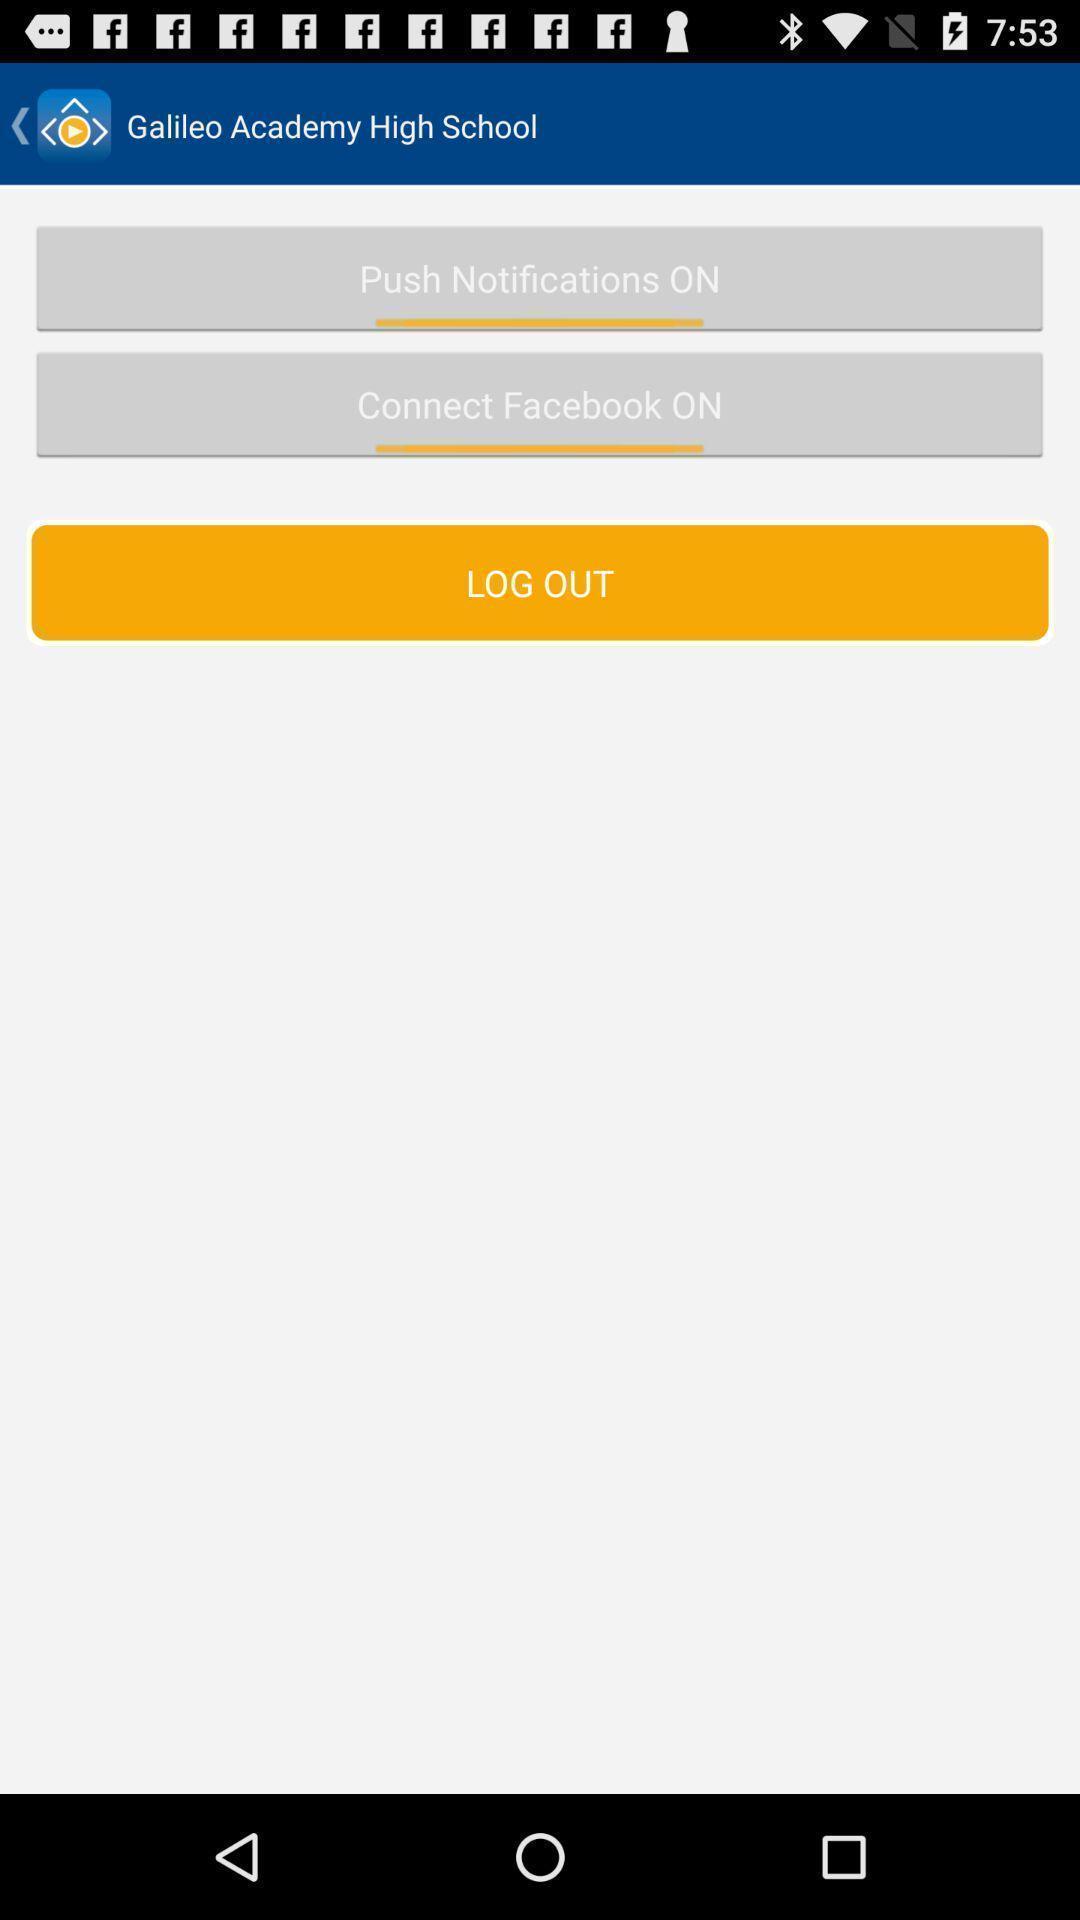What can you discern from this picture? Page showing logout option. 